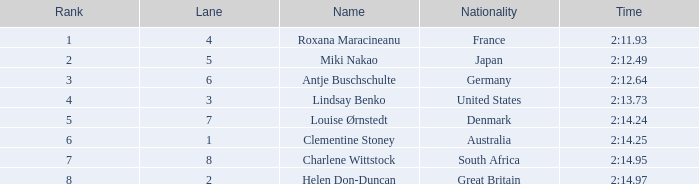What is the count of lanes with a rank greater than 2 for louise ørnstedt? 1.0. 